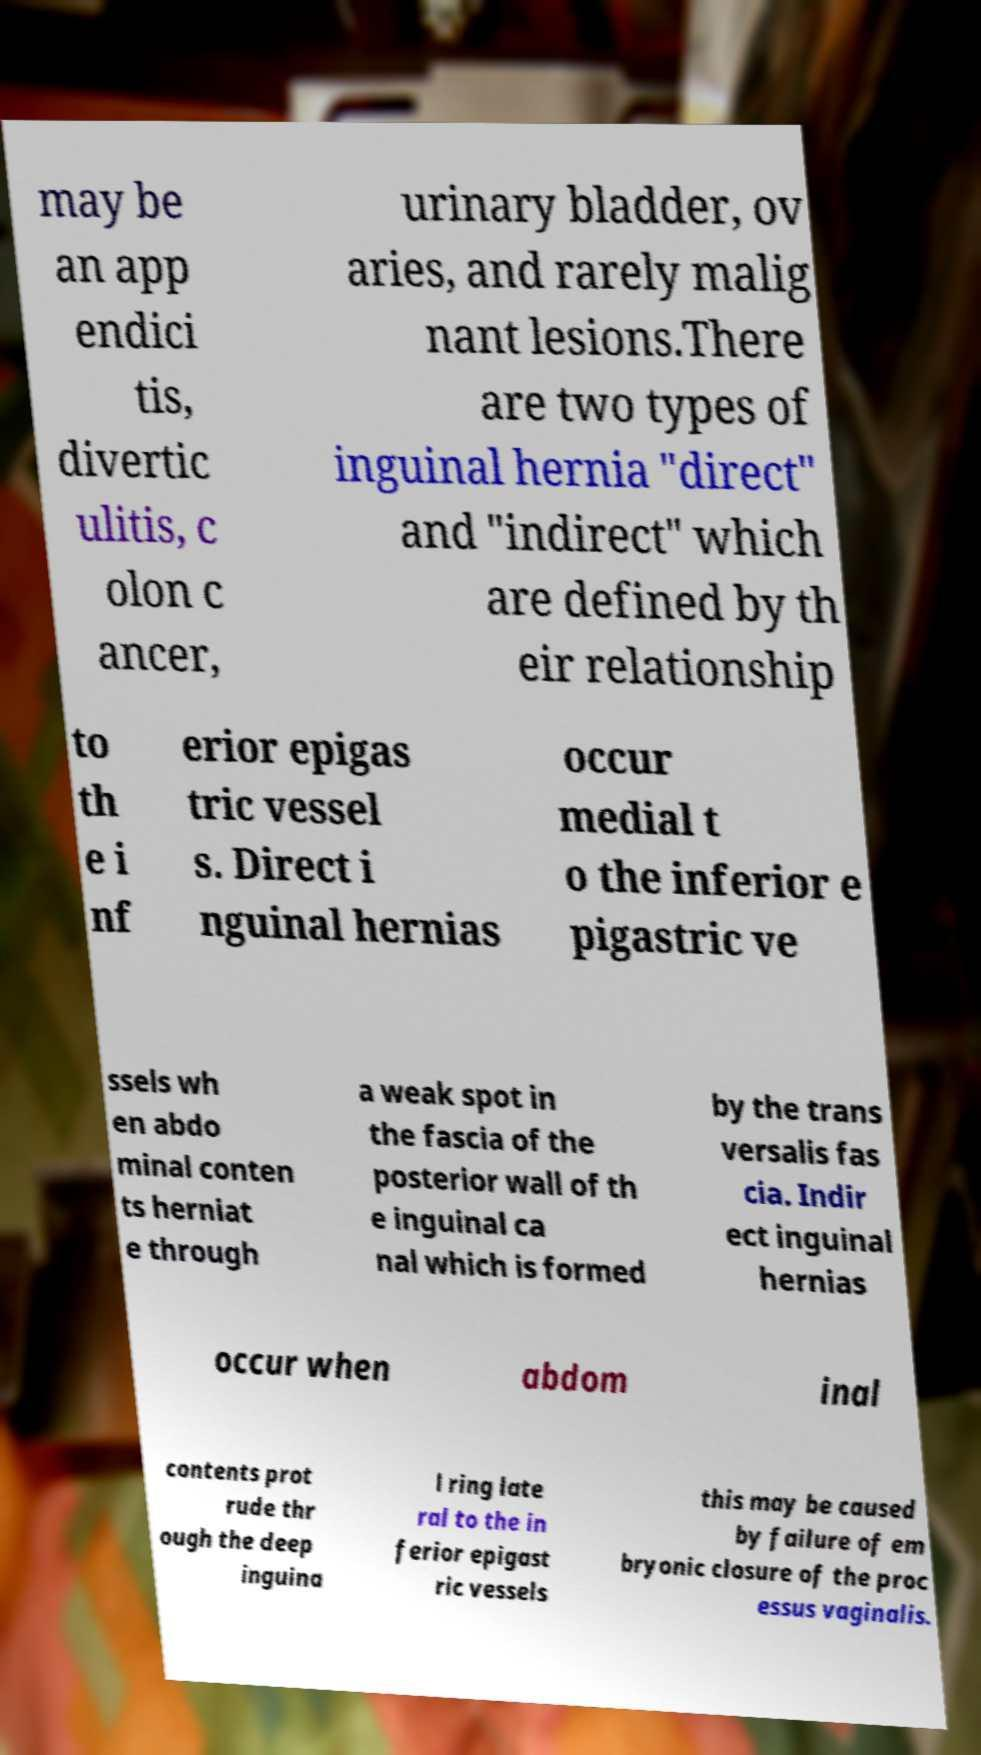Can you read and provide the text displayed in the image?This photo seems to have some interesting text. Can you extract and type it out for me? may be an app endici tis, divertic ulitis, c olon c ancer, urinary bladder, ov aries, and rarely malig nant lesions.There are two types of inguinal hernia "direct" and "indirect" which are defined by th eir relationship to th e i nf erior epigas tric vessel s. Direct i nguinal hernias occur medial t o the inferior e pigastric ve ssels wh en abdo minal conten ts herniat e through a weak spot in the fascia of the posterior wall of th e inguinal ca nal which is formed by the trans versalis fas cia. Indir ect inguinal hernias occur when abdom inal contents prot rude thr ough the deep inguina l ring late ral to the in ferior epigast ric vessels this may be caused by failure of em bryonic closure of the proc essus vaginalis. 